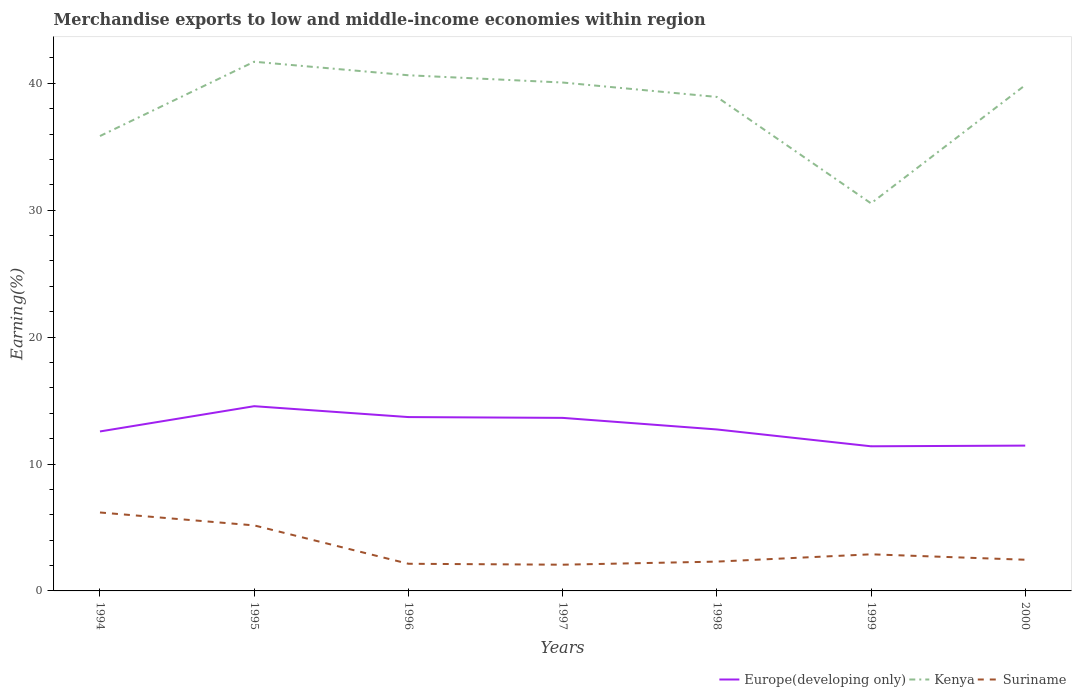Across all years, what is the maximum percentage of amount earned from merchandise exports in Europe(developing only)?
Give a very brief answer. 11.4. What is the total percentage of amount earned from merchandise exports in Suriname in the graph?
Provide a short and direct response. 1.02. What is the difference between the highest and the second highest percentage of amount earned from merchandise exports in Kenya?
Provide a succinct answer. 11.16. Is the percentage of amount earned from merchandise exports in Suriname strictly greater than the percentage of amount earned from merchandise exports in Kenya over the years?
Provide a short and direct response. Yes. How many lines are there?
Make the answer very short. 3. How many years are there in the graph?
Your answer should be very brief. 7. What is the difference between two consecutive major ticks on the Y-axis?
Your answer should be very brief. 10. Are the values on the major ticks of Y-axis written in scientific E-notation?
Offer a terse response. No. What is the title of the graph?
Offer a very short reply. Merchandise exports to low and middle-income economies within region. Does "Trinidad and Tobago" appear as one of the legend labels in the graph?
Offer a terse response. No. What is the label or title of the Y-axis?
Your response must be concise. Earning(%). What is the Earning(%) of Europe(developing only) in 1994?
Ensure brevity in your answer.  12.57. What is the Earning(%) of Kenya in 1994?
Provide a succinct answer. 35.84. What is the Earning(%) in Suriname in 1994?
Give a very brief answer. 6.18. What is the Earning(%) in Europe(developing only) in 1995?
Your answer should be compact. 14.56. What is the Earning(%) of Kenya in 1995?
Your response must be concise. 41.7. What is the Earning(%) of Suriname in 1995?
Provide a short and direct response. 5.16. What is the Earning(%) of Europe(developing only) in 1996?
Keep it short and to the point. 13.7. What is the Earning(%) of Kenya in 1996?
Provide a succinct answer. 40.63. What is the Earning(%) in Suriname in 1996?
Provide a succinct answer. 2.14. What is the Earning(%) in Europe(developing only) in 1997?
Ensure brevity in your answer.  13.64. What is the Earning(%) of Kenya in 1997?
Your response must be concise. 40.06. What is the Earning(%) of Suriname in 1997?
Provide a succinct answer. 2.07. What is the Earning(%) of Europe(developing only) in 1998?
Your answer should be compact. 12.72. What is the Earning(%) in Kenya in 1998?
Provide a short and direct response. 38.92. What is the Earning(%) of Suriname in 1998?
Keep it short and to the point. 2.31. What is the Earning(%) in Europe(developing only) in 1999?
Offer a terse response. 11.4. What is the Earning(%) in Kenya in 1999?
Give a very brief answer. 30.54. What is the Earning(%) in Suriname in 1999?
Your answer should be compact. 2.88. What is the Earning(%) of Europe(developing only) in 2000?
Ensure brevity in your answer.  11.45. What is the Earning(%) of Kenya in 2000?
Your answer should be very brief. 39.85. What is the Earning(%) in Suriname in 2000?
Make the answer very short. 2.46. Across all years, what is the maximum Earning(%) of Europe(developing only)?
Keep it short and to the point. 14.56. Across all years, what is the maximum Earning(%) of Kenya?
Keep it short and to the point. 41.7. Across all years, what is the maximum Earning(%) in Suriname?
Offer a terse response. 6.18. Across all years, what is the minimum Earning(%) of Europe(developing only)?
Offer a very short reply. 11.4. Across all years, what is the minimum Earning(%) in Kenya?
Provide a short and direct response. 30.54. Across all years, what is the minimum Earning(%) in Suriname?
Give a very brief answer. 2.07. What is the total Earning(%) in Europe(developing only) in the graph?
Make the answer very short. 90.03. What is the total Earning(%) in Kenya in the graph?
Provide a succinct answer. 267.55. What is the total Earning(%) of Suriname in the graph?
Make the answer very short. 23.2. What is the difference between the Earning(%) of Europe(developing only) in 1994 and that in 1995?
Make the answer very short. -1.99. What is the difference between the Earning(%) of Kenya in 1994 and that in 1995?
Make the answer very short. -5.86. What is the difference between the Earning(%) in Suriname in 1994 and that in 1995?
Offer a very short reply. 1.02. What is the difference between the Earning(%) in Europe(developing only) in 1994 and that in 1996?
Ensure brevity in your answer.  -1.13. What is the difference between the Earning(%) of Kenya in 1994 and that in 1996?
Provide a short and direct response. -4.79. What is the difference between the Earning(%) of Suriname in 1994 and that in 1996?
Offer a very short reply. 4.04. What is the difference between the Earning(%) of Europe(developing only) in 1994 and that in 1997?
Provide a short and direct response. -1.07. What is the difference between the Earning(%) of Kenya in 1994 and that in 1997?
Your response must be concise. -4.22. What is the difference between the Earning(%) in Suriname in 1994 and that in 1997?
Your answer should be very brief. 4.11. What is the difference between the Earning(%) of Europe(developing only) in 1994 and that in 1998?
Your answer should be compact. -0.16. What is the difference between the Earning(%) of Kenya in 1994 and that in 1998?
Offer a terse response. -3.08. What is the difference between the Earning(%) in Suriname in 1994 and that in 1998?
Your answer should be very brief. 3.87. What is the difference between the Earning(%) of Europe(developing only) in 1994 and that in 1999?
Give a very brief answer. 1.17. What is the difference between the Earning(%) in Kenya in 1994 and that in 1999?
Ensure brevity in your answer.  5.3. What is the difference between the Earning(%) of Suriname in 1994 and that in 1999?
Your answer should be very brief. 3.3. What is the difference between the Earning(%) of Europe(developing only) in 1994 and that in 2000?
Your answer should be compact. 1.12. What is the difference between the Earning(%) of Kenya in 1994 and that in 2000?
Offer a very short reply. -4.01. What is the difference between the Earning(%) in Suriname in 1994 and that in 2000?
Keep it short and to the point. 3.72. What is the difference between the Earning(%) in Europe(developing only) in 1995 and that in 1996?
Provide a succinct answer. 0.86. What is the difference between the Earning(%) of Kenya in 1995 and that in 1996?
Keep it short and to the point. 1.07. What is the difference between the Earning(%) of Suriname in 1995 and that in 1996?
Provide a short and direct response. 3.02. What is the difference between the Earning(%) of Europe(developing only) in 1995 and that in 1997?
Your answer should be very brief. 0.92. What is the difference between the Earning(%) in Kenya in 1995 and that in 1997?
Offer a terse response. 1.64. What is the difference between the Earning(%) of Suriname in 1995 and that in 1997?
Ensure brevity in your answer.  3.1. What is the difference between the Earning(%) of Europe(developing only) in 1995 and that in 1998?
Make the answer very short. 1.83. What is the difference between the Earning(%) of Kenya in 1995 and that in 1998?
Give a very brief answer. 2.77. What is the difference between the Earning(%) of Suriname in 1995 and that in 1998?
Keep it short and to the point. 2.85. What is the difference between the Earning(%) of Europe(developing only) in 1995 and that in 1999?
Provide a succinct answer. 3.16. What is the difference between the Earning(%) in Kenya in 1995 and that in 1999?
Ensure brevity in your answer.  11.16. What is the difference between the Earning(%) of Suriname in 1995 and that in 1999?
Provide a succinct answer. 2.28. What is the difference between the Earning(%) in Europe(developing only) in 1995 and that in 2000?
Give a very brief answer. 3.11. What is the difference between the Earning(%) in Kenya in 1995 and that in 2000?
Ensure brevity in your answer.  1.84. What is the difference between the Earning(%) of Suriname in 1995 and that in 2000?
Keep it short and to the point. 2.71. What is the difference between the Earning(%) in Europe(developing only) in 1996 and that in 1997?
Give a very brief answer. 0.06. What is the difference between the Earning(%) in Kenya in 1996 and that in 1997?
Your answer should be compact. 0.57. What is the difference between the Earning(%) of Suriname in 1996 and that in 1997?
Offer a terse response. 0.07. What is the difference between the Earning(%) of Europe(developing only) in 1996 and that in 1998?
Your answer should be compact. 0.97. What is the difference between the Earning(%) in Kenya in 1996 and that in 1998?
Keep it short and to the point. 1.71. What is the difference between the Earning(%) of Suriname in 1996 and that in 1998?
Your answer should be compact. -0.17. What is the difference between the Earning(%) in Europe(developing only) in 1996 and that in 1999?
Offer a terse response. 2.3. What is the difference between the Earning(%) of Kenya in 1996 and that in 1999?
Keep it short and to the point. 10.09. What is the difference between the Earning(%) in Suriname in 1996 and that in 1999?
Your answer should be very brief. -0.75. What is the difference between the Earning(%) in Europe(developing only) in 1996 and that in 2000?
Offer a very short reply. 2.25. What is the difference between the Earning(%) of Kenya in 1996 and that in 2000?
Your answer should be compact. 0.78. What is the difference between the Earning(%) of Suriname in 1996 and that in 2000?
Your response must be concise. -0.32. What is the difference between the Earning(%) of Europe(developing only) in 1997 and that in 1998?
Give a very brief answer. 0.91. What is the difference between the Earning(%) of Kenya in 1997 and that in 1998?
Give a very brief answer. 1.14. What is the difference between the Earning(%) of Suriname in 1997 and that in 1998?
Your response must be concise. -0.24. What is the difference between the Earning(%) of Europe(developing only) in 1997 and that in 1999?
Make the answer very short. 2.24. What is the difference between the Earning(%) of Kenya in 1997 and that in 1999?
Provide a succinct answer. 9.52. What is the difference between the Earning(%) of Suriname in 1997 and that in 1999?
Offer a very short reply. -0.82. What is the difference between the Earning(%) of Europe(developing only) in 1997 and that in 2000?
Your answer should be compact. 2.19. What is the difference between the Earning(%) in Kenya in 1997 and that in 2000?
Give a very brief answer. 0.21. What is the difference between the Earning(%) in Suriname in 1997 and that in 2000?
Provide a succinct answer. -0.39. What is the difference between the Earning(%) in Europe(developing only) in 1998 and that in 1999?
Offer a terse response. 1.33. What is the difference between the Earning(%) of Kenya in 1998 and that in 1999?
Ensure brevity in your answer.  8.39. What is the difference between the Earning(%) in Suriname in 1998 and that in 1999?
Give a very brief answer. -0.58. What is the difference between the Earning(%) of Europe(developing only) in 1998 and that in 2000?
Provide a short and direct response. 1.27. What is the difference between the Earning(%) of Kenya in 1998 and that in 2000?
Provide a short and direct response. -0.93. What is the difference between the Earning(%) of Suriname in 1998 and that in 2000?
Your answer should be compact. -0.15. What is the difference between the Earning(%) of Europe(developing only) in 1999 and that in 2000?
Give a very brief answer. -0.05. What is the difference between the Earning(%) of Kenya in 1999 and that in 2000?
Offer a terse response. -9.32. What is the difference between the Earning(%) in Suriname in 1999 and that in 2000?
Keep it short and to the point. 0.43. What is the difference between the Earning(%) in Europe(developing only) in 1994 and the Earning(%) in Kenya in 1995?
Provide a short and direct response. -29.13. What is the difference between the Earning(%) in Europe(developing only) in 1994 and the Earning(%) in Suriname in 1995?
Give a very brief answer. 7.4. What is the difference between the Earning(%) of Kenya in 1994 and the Earning(%) of Suriname in 1995?
Your answer should be compact. 30.68. What is the difference between the Earning(%) of Europe(developing only) in 1994 and the Earning(%) of Kenya in 1996?
Provide a succinct answer. -28.07. What is the difference between the Earning(%) of Europe(developing only) in 1994 and the Earning(%) of Suriname in 1996?
Ensure brevity in your answer.  10.43. What is the difference between the Earning(%) in Kenya in 1994 and the Earning(%) in Suriname in 1996?
Your answer should be compact. 33.7. What is the difference between the Earning(%) in Europe(developing only) in 1994 and the Earning(%) in Kenya in 1997?
Provide a short and direct response. -27.49. What is the difference between the Earning(%) in Europe(developing only) in 1994 and the Earning(%) in Suriname in 1997?
Make the answer very short. 10.5. What is the difference between the Earning(%) of Kenya in 1994 and the Earning(%) of Suriname in 1997?
Your response must be concise. 33.78. What is the difference between the Earning(%) in Europe(developing only) in 1994 and the Earning(%) in Kenya in 1998?
Make the answer very short. -26.36. What is the difference between the Earning(%) of Europe(developing only) in 1994 and the Earning(%) of Suriname in 1998?
Provide a short and direct response. 10.26. What is the difference between the Earning(%) of Kenya in 1994 and the Earning(%) of Suriname in 1998?
Offer a terse response. 33.53. What is the difference between the Earning(%) in Europe(developing only) in 1994 and the Earning(%) in Kenya in 1999?
Your answer should be compact. -17.97. What is the difference between the Earning(%) in Europe(developing only) in 1994 and the Earning(%) in Suriname in 1999?
Make the answer very short. 9.68. What is the difference between the Earning(%) of Kenya in 1994 and the Earning(%) of Suriname in 1999?
Make the answer very short. 32.96. What is the difference between the Earning(%) in Europe(developing only) in 1994 and the Earning(%) in Kenya in 2000?
Your answer should be very brief. -27.29. What is the difference between the Earning(%) in Europe(developing only) in 1994 and the Earning(%) in Suriname in 2000?
Your answer should be very brief. 10.11. What is the difference between the Earning(%) of Kenya in 1994 and the Earning(%) of Suriname in 2000?
Your response must be concise. 33.39. What is the difference between the Earning(%) of Europe(developing only) in 1995 and the Earning(%) of Kenya in 1996?
Your answer should be compact. -26.08. What is the difference between the Earning(%) of Europe(developing only) in 1995 and the Earning(%) of Suriname in 1996?
Ensure brevity in your answer.  12.42. What is the difference between the Earning(%) of Kenya in 1995 and the Earning(%) of Suriname in 1996?
Make the answer very short. 39.56. What is the difference between the Earning(%) of Europe(developing only) in 1995 and the Earning(%) of Kenya in 1997?
Provide a short and direct response. -25.5. What is the difference between the Earning(%) of Europe(developing only) in 1995 and the Earning(%) of Suriname in 1997?
Your answer should be very brief. 12.49. What is the difference between the Earning(%) in Kenya in 1995 and the Earning(%) in Suriname in 1997?
Your answer should be very brief. 39.63. What is the difference between the Earning(%) in Europe(developing only) in 1995 and the Earning(%) in Kenya in 1998?
Make the answer very short. -24.37. What is the difference between the Earning(%) of Europe(developing only) in 1995 and the Earning(%) of Suriname in 1998?
Ensure brevity in your answer.  12.25. What is the difference between the Earning(%) in Kenya in 1995 and the Earning(%) in Suriname in 1998?
Offer a very short reply. 39.39. What is the difference between the Earning(%) of Europe(developing only) in 1995 and the Earning(%) of Kenya in 1999?
Give a very brief answer. -15.98. What is the difference between the Earning(%) of Europe(developing only) in 1995 and the Earning(%) of Suriname in 1999?
Offer a terse response. 11.67. What is the difference between the Earning(%) of Kenya in 1995 and the Earning(%) of Suriname in 1999?
Your answer should be compact. 38.81. What is the difference between the Earning(%) in Europe(developing only) in 1995 and the Earning(%) in Kenya in 2000?
Provide a succinct answer. -25.3. What is the difference between the Earning(%) in Europe(developing only) in 1995 and the Earning(%) in Suriname in 2000?
Offer a terse response. 12.1. What is the difference between the Earning(%) of Kenya in 1995 and the Earning(%) of Suriname in 2000?
Provide a succinct answer. 39.24. What is the difference between the Earning(%) in Europe(developing only) in 1996 and the Earning(%) in Kenya in 1997?
Your answer should be very brief. -26.36. What is the difference between the Earning(%) in Europe(developing only) in 1996 and the Earning(%) in Suriname in 1997?
Ensure brevity in your answer.  11.63. What is the difference between the Earning(%) in Kenya in 1996 and the Earning(%) in Suriname in 1997?
Make the answer very short. 38.57. What is the difference between the Earning(%) of Europe(developing only) in 1996 and the Earning(%) of Kenya in 1998?
Ensure brevity in your answer.  -25.23. What is the difference between the Earning(%) in Europe(developing only) in 1996 and the Earning(%) in Suriname in 1998?
Make the answer very short. 11.39. What is the difference between the Earning(%) in Kenya in 1996 and the Earning(%) in Suriname in 1998?
Ensure brevity in your answer.  38.32. What is the difference between the Earning(%) in Europe(developing only) in 1996 and the Earning(%) in Kenya in 1999?
Ensure brevity in your answer.  -16.84. What is the difference between the Earning(%) in Europe(developing only) in 1996 and the Earning(%) in Suriname in 1999?
Keep it short and to the point. 10.81. What is the difference between the Earning(%) of Kenya in 1996 and the Earning(%) of Suriname in 1999?
Keep it short and to the point. 37.75. What is the difference between the Earning(%) in Europe(developing only) in 1996 and the Earning(%) in Kenya in 2000?
Your answer should be compact. -26.16. What is the difference between the Earning(%) in Europe(developing only) in 1996 and the Earning(%) in Suriname in 2000?
Make the answer very short. 11.24. What is the difference between the Earning(%) of Kenya in 1996 and the Earning(%) of Suriname in 2000?
Ensure brevity in your answer.  38.17. What is the difference between the Earning(%) in Europe(developing only) in 1997 and the Earning(%) in Kenya in 1998?
Ensure brevity in your answer.  -25.29. What is the difference between the Earning(%) of Europe(developing only) in 1997 and the Earning(%) of Suriname in 1998?
Offer a terse response. 11.33. What is the difference between the Earning(%) in Kenya in 1997 and the Earning(%) in Suriname in 1998?
Provide a short and direct response. 37.75. What is the difference between the Earning(%) of Europe(developing only) in 1997 and the Earning(%) of Kenya in 1999?
Offer a very short reply. -16.9. What is the difference between the Earning(%) of Europe(developing only) in 1997 and the Earning(%) of Suriname in 1999?
Offer a very short reply. 10.75. What is the difference between the Earning(%) in Kenya in 1997 and the Earning(%) in Suriname in 1999?
Give a very brief answer. 37.18. What is the difference between the Earning(%) in Europe(developing only) in 1997 and the Earning(%) in Kenya in 2000?
Give a very brief answer. -26.22. What is the difference between the Earning(%) of Europe(developing only) in 1997 and the Earning(%) of Suriname in 2000?
Keep it short and to the point. 11.18. What is the difference between the Earning(%) in Kenya in 1997 and the Earning(%) in Suriname in 2000?
Give a very brief answer. 37.6. What is the difference between the Earning(%) in Europe(developing only) in 1998 and the Earning(%) in Kenya in 1999?
Offer a very short reply. -17.81. What is the difference between the Earning(%) of Europe(developing only) in 1998 and the Earning(%) of Suriname in 1999?
Provide a succinct answer. 9.84. What is the difference between the Earning(%) in Kenya in 1998 and the Earning(%) in Suriname in 1999?
Give a very brief answer. 36.04. What is the difference between the Earning(%) in Europe(developing only) in 1998 and the Earning(%) in Kenya in 2000?
Your answer should be compact. -27.13. What is the difference between the Earning(%) in Europe(developing only) in 1998 and the Earning(%) in Suriname in 2000?
Make the answer very short. 10.27. What is the difference between the Earning(%) of Kenya in 1998 and the Earning(%) of Suriname in 2000?
Provide a succinct answer. 36.47. What is the difference between the Earning(%) of Europe(developing only) in 1999 and the Earning(%) of Kenya in 2000?
Provide a short and direct response. -28.46. What is the difference between the Earning(%) in Europe(developing only) in 1999 and the Earning(%) in Suriname in 2000?
Provide a short and direct response. 8.94. What is the difference between the Earning(%) in Kenya in 1999 and the Earning(%) in Suriname in 2000?
Provide a short and direct response. 28.08. What is the average Earning(%) in Europe(developing only) per year?
Provide a short and direct response. 12.86. What is the average Earning(%) of Kenya per year?
Keep it short and to the point. 38.22. What is the average Earning(%) in Suriname per year?
Your answer should be very brief. 3.31. In the year 1994, what is the difference between the Earning(%) of Europe(developing only) and Earning(%) of Kenya?
Your answer should be compact. -23.28. In the year 1994, what is the difference between the Earning(%) in Europe(developing only) and Earning(%) in Suriname?
Provide a short and direct response. 6.39. In the year 1994, what is the difference between the Earning(%) in Kenya and Earning(%) in Suriname?
Offer a terse response. 29.66. In the year 1995, what is the difference between the Earning(%) of Europe(developing only) and Earning(%) of Kenya?
Ensure brevity in your answer.  -27.14. In the year 1995, what is the difference between the Earning(%) in Europe(developing only) and Earning(%) in Suriname?
Keep it short and to the point. 9.39. In the year 1995, what is the difference between the Earning(%) of Kenya and Earning(%) of Suriname?
Make the answer very short. 36.54. In the year 1996, what is the difference between the Earning(%) in Europe(developing only) and Earning(%) in Kenya?
Provide a succinct answer. -26.93. In the year 1996, what is the difference between the Earning(%) of Europe(developing only) and Earning(%) of Suriname?
Your response must be concise. 11.56. In the year 1996, what is the difference between the Earning(%) in Kenya and Earning(%) in Suriname?
Your answer should be very brief. 38.49. In the year 1997, what is the difference between the Earning(%) of Europe(developing only) and Earning(%) of Kenya?
Give a very brief answer. -26.42. In the year 1997, what is the difference between the Earning(%) in Europe(developing only) and Earning(%) in Suriname?
Give a very brief answer. 11.57. In the year 1997, what is the difference between the Earning(%) of Kenya and Earning(%) of Suriname?
Ensure brevity in your answer.  37.99. In the year 1998, what is the difference between the Earning(%) in Europe(developing only) and Earning(%) in Kenya?
Give a very brief answer. -26.2. In the year 1998, what is the difference between the Earning(%) of Europe(developing only) and Earning(%) of Suriname?
Keep it short and to the point. 10.41. In the year 1998, what is the difference between the Earning(%) in Kenya and Earning(%) in Suriname?
Offer a terse response. 36.62. In the year 1999, what is the difference between the Earning(%) in Europe(developing only) and Earning(%) in Kenya?
Make the answer very short. -19.14. In the year 1999, what is the difference between the Earning(%) in Europe(developing only) and Earning(%) in Suriname?
Your response must be concise. 8.51. In the year 1999, what is the difference between the Earning(%) in Kenya and Earning(%) in Suriname?
Keep it short and to the point. 27.65. In the year 2000, what is the difference between the Earning(%) of Europe(developing only) and Earning(%) of Kenya?
Your answer should be very brief. -28.4. In the year 2000, what is the difference between the Earning(%) in Europe(developing only) and Earning(%) in Suriname?
Provide a short and direct response. 8.99. In the year 2000, what is the difference between the Earning(%) of Kenya and Earning(%) of Suriname?
Offer a terse response. 37.4. What is the ratio of the Earning(%) of Europe(developing only) in 1994 to that in 1995?
Keep it short and to the point. 0.86. What is the ratio of the Earning(%) of Kenya in 1994 to that in 1995?
Make the answer very short. 0.86. What is the ratio of the Earning(%) of Suriname in 1994 to that in 1995?
Ensure brevity in your answer.  1.2. What is the ratio of the Earning(%) of Europe(developing only) in 1994 to that in 1996?
Provide a short and direct response. 0.92. What is the ratio of the Earning(%) of Kenya in 1994 to that in 1996?
Provide a short and direct response. 0.88. What is the ratio of the Earning(%) in Suriname in 1994 to that in 1996?
Your response must be concise. 2.89. What is the ratio of the Earning(%) of Europe(developing only) in 1994 to that in 1997?
Give a very brief answer. 0.92. What is the ratio of the Earning(%) in Kenya in 1994 to that in 1997?
Provide a short and direct response. 0.89. What is the ratio of the Earning(%) of Suriname in 1994 to that in 1997?
Your answer should be very brief. 2.99. What is the ratio of the Earning(%) in Europe(developing only) in 1994 to that in 1998?
Your answer should be compact. 0.99. What is the ratio of the Earning(%) of Kenya in 1994 to that in 1998?
Offer a terse response. 0.92. What is the ratio of the Earning(%) in Suriname in 1994 to that in 1998?
Provide a succinct answer. 2.68. What is the ratio of the Earning(%) of Europe(developing only) in 1994 to that in 1999?
Give a very brief answer. 1.1. What is the ratio of the Earning(%) in Kenya in 1994 to that in 1999?
Give a very brief answer. 1.17. What is the ratio of the Earning(%) in Suriname in 1994 to that in 1999?
Ensure brevity in your answer.  2.14. What is the ratio of the Earning(%) of Europe(developing only) in 1994 to that in 2000?
Offer a terse response. 1.1. What is the ratio of the Earning(%) of Kenya in 1994 to that in 2000?
Offer a very short reply. 0.9. What is the ratio of the Earning(%) of Suriname in 1994 to that in 2000?
Offer a terse response. 2.52. What is the ratio of the Earning(%) in Europe(developing only) in 1995 to that in 1996?
Give a very brief answer. 1.06. What is the ratio of the Earning(%) of Kenya in 1995 to that in 1996?
Provide a short and direct response. 1.03. What is the ratio of the Earning(%) in Suriname in 1995 to that in 1996?
Keep it short and to the point. 2.41. What is the ratio of the Earning(%) in Europe(developing only) in 1995 to that in 1997?
Keep it short and to the point. 1.07. What is the ratio of the Earning(%) in Kenya in 1995 to that in 1997?
Your answer should be very brief. 1.04. What is the ratio of the Earning(%) in Suriname in 1995 to that in 1997?
Offer a very short reply. 2.5. What is the ratio of the Earning(%) in Europe(developing only) in 1995 to that in 1998?
Your response must be concise. 1.14. What is the ratio of the Earning(%) of Kenya in 1995 to that in 1998?
Ensure brevity in your answer.  1.07. What is the ratio of the Earning(%) of Suriname in 1995 to that in 1998?
Keep it short and to the point. 2.24. What is the ratio of the Earning(%) of Europe(developing only) in 1995 to that in 1999?
Keep it short and to the point. 1.28. What is the ratio of the Earning(%) of Kenya in 1995 to that in 1999?
Make the answer very short. 1.37. What is the ratio of the Earning(%) of Suriname in 1995 to that in 1999?
Provide a succinct answer. 1.79. What is the ratio of the Earning(%) of Europe(developing only) in 1995 to that in 2000?
Provide a succinct answer. 1.27. What is the ratio of the Earning(%) of Kenya in 1995 to that in 2000?
Your answer should be very brief. 1.05. What is the ratio of the Earning(%) of Suriname in 1995 to that in 2000?
Provide a short and direct response. 2.1. What is the ratio of the Earning(%) in Europe(developing only) in 1996 to that in 1997?
Your answer should be compact. 1. What is the ratio of the Earning(%) in Kenya in 1996 to that in 1997?
Your answer should be compact. 1.01. What is the ratio of the Earning(%) in Suriname in 1996 to that in 1997?
Make the answer very short. 1.04. What is the ratio of the Earning(%) in Europe(developing only) in 1996 to that in 1998?
Your response must be concise. 1.08. What is the ratio of the Earning(%) of Kenya in 1996 to that in 1998?
Make the answer very short. 1.04. What is the ratio of the Earning(%) in Suriname in 1996 to that in 1998?
Provide a succinct answer. 0.93. What is the ratio of the Earning(%) in Europe(developing only) in 1996 to that in 1999?
Provide a short and direct response. 1.2. What is the ratio of the Earning(%) of Kenya in 1996 to that in 1999?
Your answer should be very brief. 1.33. What is the ratio of the Earning(%) of Suriname in 1996 to that in 1999?
Provide a short and direct response. 0.74. What is the ratio of the Earning(%) in Europe(developing only) in 1996 to that in 2000?
Your answer should be compact. 1.2. What is the ratio of the Earning(%) of Kenya in 1996 to that in 2000?
Make the answer very short. 1.02. What is the ratio of the Earning(%) of Suriname in 1996 to that in 2000?
Provide a succinct answer. 0.87. What is the ratio of the Earning(%) of Europe(developing only) in 1997 to that in 1998?
Ensure brevity in your answer.  1.07. What is the ratio of the Earning(%) in Kenya in 1997 to that in 1998?
Your response must be concise. 1.03. What is the ratio of the Earning(%) of Suriname in 1997 to that in 1998?
Offer a terse response. 0.89. What is the ratio of the Earning(%) in Europe(developing only) in 1997 to that in 1999?
Your response must be concise. 1.2. What is the ratio of the Earning(%) of Kenya in 1997 to that in 1999?
Ensure brevity in your answer.  1.31. What is the ratio of the Earning(%) of Suriname in 1997 to that in 1999?
Provide a succinct answer. 0.72. What is the ratio of the Earning(%) of Europe(developing only) in 1997 to that in 2000?
Provide a short and direct response. 1.19. What is the ratio of the Earning(%) in Kenya in 1997 to that in 2000?
Provide a short and direct response. 1.01. What is the ratio of the Earning(%) in Suriname in 1997 to that in 2000?
Make the answer very short. 0.84. What is the ratio of the Earning(%) of Europe(developing only) in 1998 to that in 1999?
Give a very brief answer. 1.12. What is the ratio of the Earning(%) in Kenya in 1998 to that in 1999?
Make the answer very short. 1.27. What is the ratio of the Earning(%) in Suriname in 1998 to that in 1999?
Your answer should be compact. 0.8. What is the ratio of the Earning(%) in Europe(developing only) in 1998 to that in 2000?
Give a very brief answer. 1.11. What is the ratio of the Earning(%) of Kenya in 1998 to that in 2000?
Your answer should be very brief. 0.98. What is the ratio of the Earning(%) in Suriname in 1998 to that in 2000?
Give a very brief answer. 0.94. What is the ratio of the Earning(%) in Europe(developing only) in 1999 to that in 2000?
Your response must be concise. 1. What is the ratio of the Earning(%) of Kenya in 1999 to that in 2000?
Keep it short and to the point. 0.77. What is the ratio of the Earning(%) in Suriname in 1999 to that in 2000?
Provide a short and direct response. 1.17. What is the difference between the highest and the second highest Earning(%) in Europe(developing only)?
Offer a terse response. 0.86. What is the difference between the highest and the second highest Earning(%) in Kenya?
Your answer should be compact. 1.07. What is the difference between the highest and the second highest Earning(%) in Suriname?
Provide a succinct answer. 1.02. What is the difference between the highest and the lowest Earning(%) in Europe(developing only)?
Provide a succinct answer. 3.16. What is the difference between the highest and the lowest Earning(%) in Kenya?
Your answer should be compact. 11.16. What is the difference between the highest and the lowest Earning(%) of Suriname?
Provide a short and direct response. 4.11. 